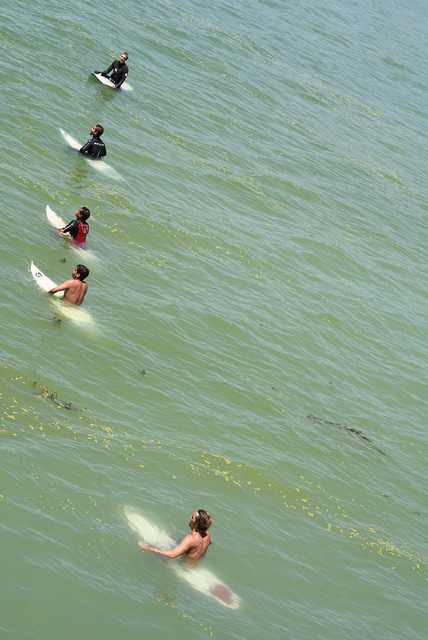Do the surfers in the image appear to be beginners or experienced? It's not entirely clear from the image, as there are no active waves being ridden. However, their positioning and spacing in the water suggest they have an understanding of surf etiquette, which may indicate a level of experience. What are some indicators that could help determine their skill level? Some indicators might include the surfers' stances on the boards, their techniques in navigating waves, the steadiness of their board-handling, and any maneuvers they perform. Without observing them in action, though, these assessments remain speculative. 